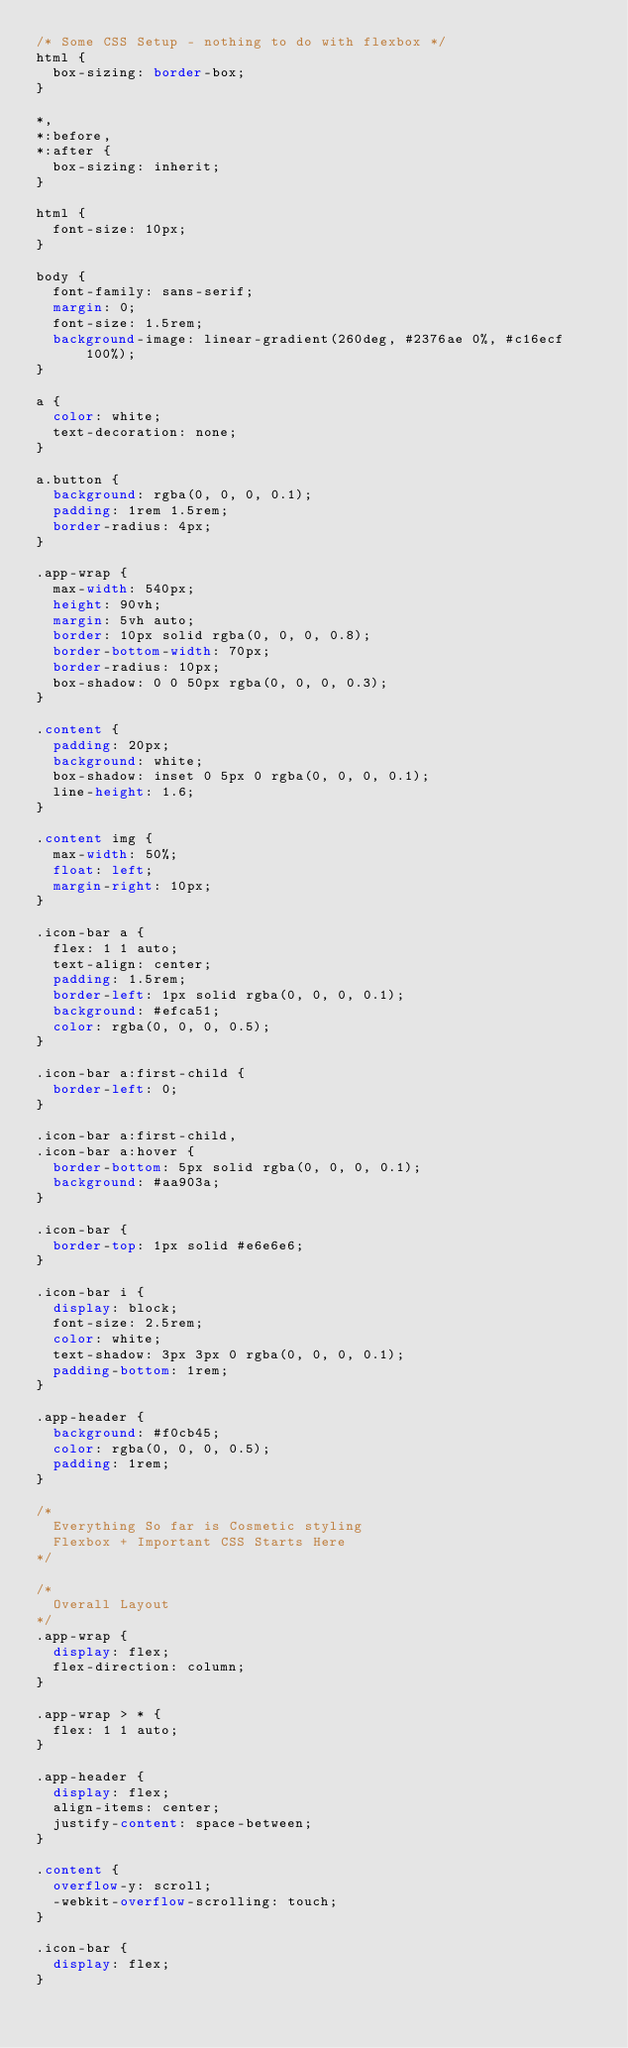Convert code to text. <code><loc_0><loc_0><loc_500><loc_500><_CSS_>/* Some CSS Setup - nothing to do with flexbox */
html {
  box-sizing: border-box;
}

*,
*:before,
*:after {
  box-sizing: inherit;
}

html {
  font-size: 10px;
}

body {
  font-family: sans-serif;
  margin: 0;
  font-size: 1.5rem;
  background-image: linear-gradient(260deg, #2376ae 0%, #c16ecf 100%);
}

a {
  color: white;
  text-decoration: none;
}

a.button {
  background: rgba(0, 0, 0, 0.1);
  padding: 1rem 1.5rem;
  border-radius: 4px;
}

.app-wrap {
  max-width: 540px;
  height: 90vh;
  margin: 5vh auto;
  border: 10px solid rgba(0, 0, 0, 0.8);
  border-bottom-width: 70px;
  border-radius: 10px;
  box-shadow: 0 0 50px rgba(0, 0, 0, 0.3);
}

.content {
  padding: 20px;
  background: white;
  box-shadow: inset 0 5px 0 rgba(0, 0, 0, 0.1);
  line-height: 1.6;
}

.content img {
  max-width: 50%;
  float: left;
  margin-right: 10px;
}

.icon-bar a {
  flex: 1 1 auto;
  text-align: center;
  padding: 1.5rem;
  border-left: 1px solid rgba(0, 0, 0, 0.1);
  background: #efca51;
  color: rgba(0, 0, 0, 0.5);
}

.icon-bar a:first-child {
  border-left: 0;
}

.icon-bar a:first-child,
.icon-bar a:hover {
  border-bottom: 5px solid rgba(0, 0, 0, 0.1);
  background: #aa903a;
}

.icon-bar {
  border-top: 1px solid #e6e6e6;
}

.icon-bar i {
  display: block;
  font-size: 2.5rem;
  color: white;
  text-shadow: 3px 3px 0 rgba(0, 0, 0, 0.1);
  padding-bottom: 1rem;
}

.app-header {
  background: #f0cb45;
  color: rgba(0, 0, 0, 0.5);
  padding: 1rem;
}

/*
  Everything So far is Cosmetic styling 
  Flexbox + Important CSS Starts Here
*/

/*
  Overall Layout
*/
.app-wrap {
  display: flex;
  flex-direction: column;
}

.app-wrap > * {
  flex: 1 1 auto;
}

.app-header {
  display: flex;
  align-items: center;
  justify-content: space-between;
}

.content {
  overflow-y: scroll;
  -webkit-overflow-scrolling: touch;
}

.icon-bar {
  display: flex;
}
</code> 